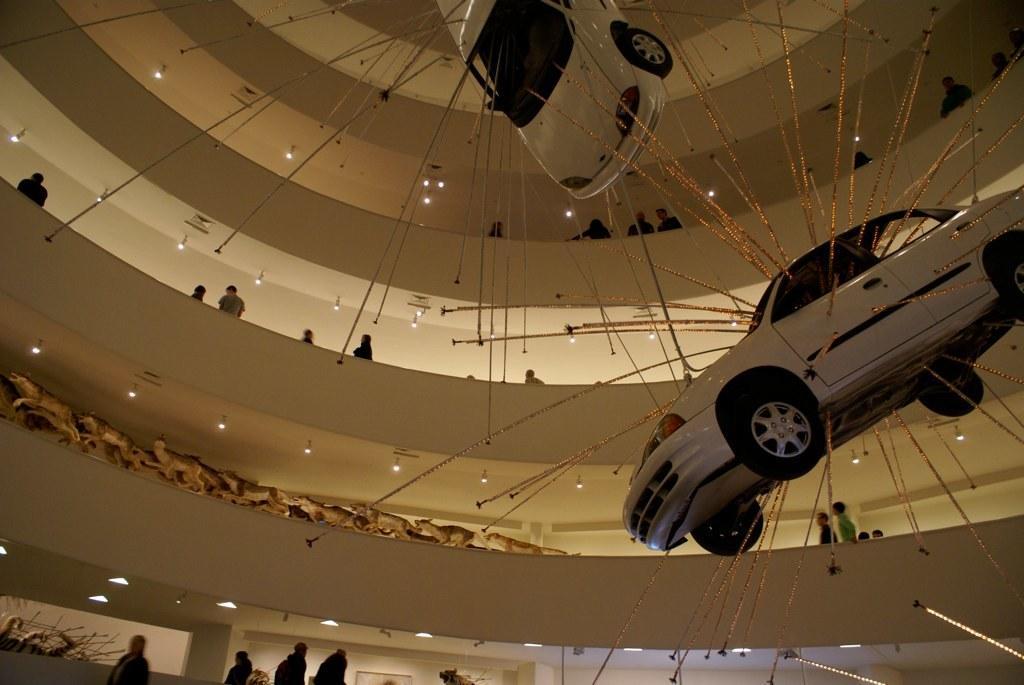In one or two sentences, can you explain what this image depicts? Here we can see two cars and there are few persons. This is a building and there are lights. 